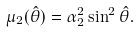Convert formula to latex. <formula><loc_0><loc_0><loc_500><loc_500>\mu _ { 2 } ( \hat { \theta } ) = \alpha _ { 2 } ^ { 2 } \sin ^ { 2 } { \hat { \theta } } .</formula> 